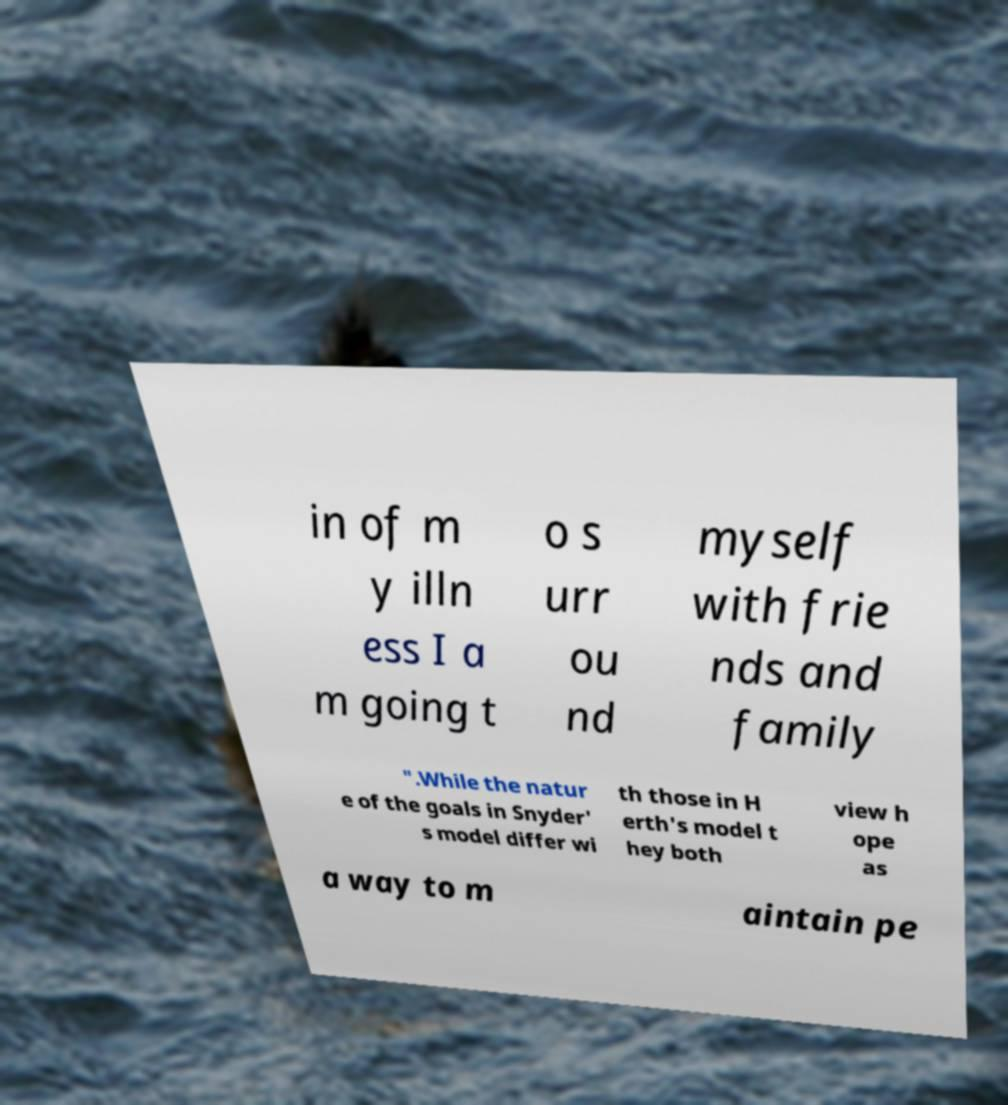Please identify and transcribe the text found in this image. in of m y illn ess I a m going t o s urr ou nd myself with frie nds and family ".While the natur e of the goals in Snyder' s model differ wi th those in H erth's model t hey both view h ope as a way to m aintain pe 